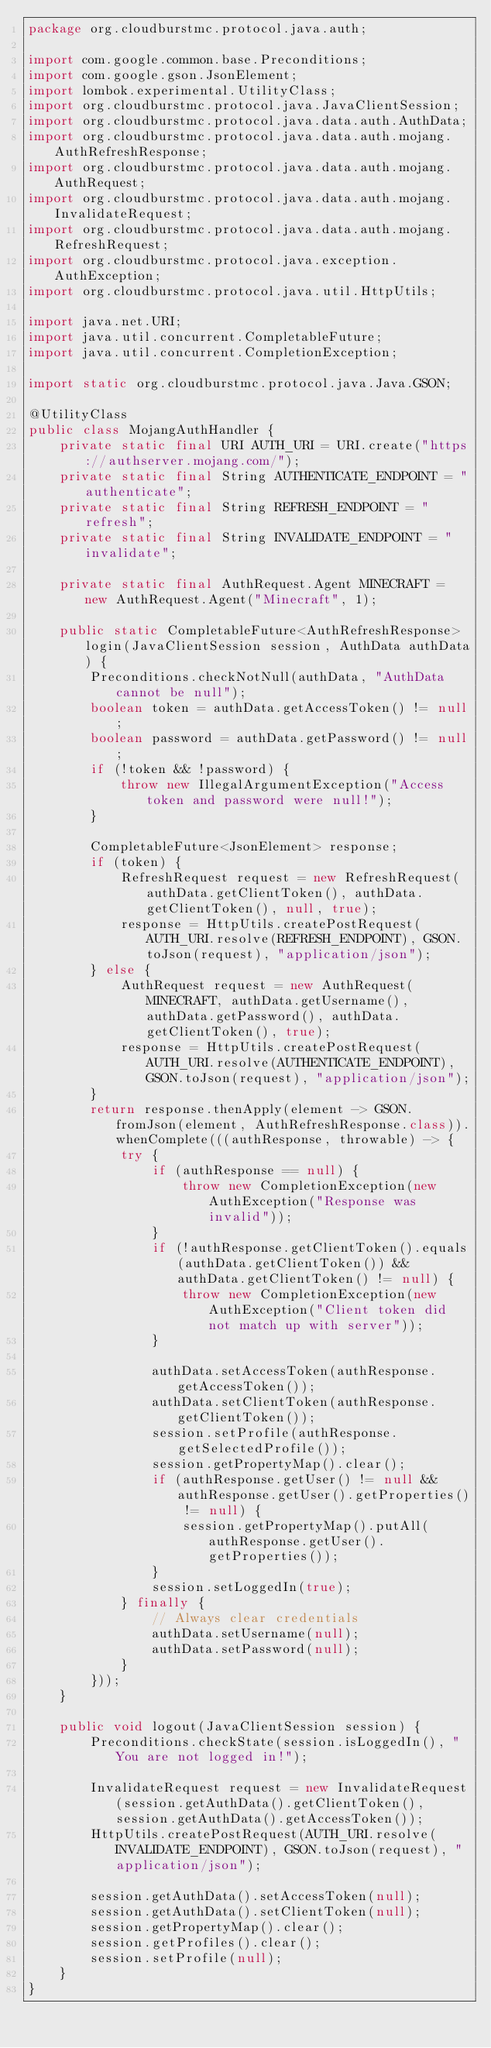<code> <loc_0><loc_0><loc_500><loc_500><_Java_>package org.cloudburstmc.protocol.java.auth;

import com.google.common.base.Preconditions;
import com.google.gson.JsonElement;
import lombok.experimental.UtilityClass;
import org.cloudburstmc.protocol.java.JavaClientSession;
import org.cloudburstmc.protocol.java.data.auth.AuthData;
import org.cloudburstmc.protocol.java.data.auth.mojang.AuthRefreshResponse;
import org.cloudburstmc.protocol.java.data.auth.mojang.AuthRequest;
import org.cloudburstmc.protocol.java.data.auth.mojang.InvalidateRequest;
import org.cloudburstmc.protocol.java.data.auth.mojang.RefreshRequest;
import org.cloudburstmc.protocol.java.exception.AuthException;
import org.cloudburstmc.protocol.java.util.HttpUtils;

import java.net.URI;
import java.util.concurrent.CompletableFuture;
import java.util.concurrent.CompletionException;

import static org.cloudburstmc.protocol.java.Java.GSON;

@UtilityClass
public class MojangAuthHandler {
    private static final URI AUTH_URI = URI.create("https://authserver.mojang.com/");
    private static final String AUTHENTICATE_ENDPOINT = "authenticate";
    private static final String REFRESH_ENDPOINT = "refresh";
    private static final String INVALIDATE_ENDPOINT = "invalidate";

    private static final AuthRequest.Agent MINECRAFT = new AuthRequest.Agent("Minecraft", 1);

    public static CompletableFuture<AuthRefreshResponse> login(JavaClientSession session, AuthData authData) {
        Preconditions.checkNotNull(authData, "AuthData cannot be null");
        boolean token = authData.getAccessToken() != null;
        boolean password = authData.getPassword() != null;
        if (!token && !password) {
            throw new IllegalArgumentException("Access token and password were null!");
        }

        CompletableFuture<JsonElement> response;
        if (token) {
            RefreshRequest request = new RefreshRequest(authData.getClientToken(), authData.getClientToken(), null, true);
            response = HttpUtils.createPostRequest(AUTH_URI.resolve(REFRESH_ENDPOINT), GSON.toJson(request), "application/json");
        } else {
            AuthRequest request = new AuthRequest(MINECRAFT, authData.getUsername(), authData.getPassword(), authData.getClientToken(), true);
            response = HttpUtils.createPostRequest(AUTH_URI.resolve(AUTHENTICATE_ENDPOINT), GSON.toJson(request), "application/json");
        }
        return response.thenApply(element -> GSON.fromJson(element, AuthRefreshResponse.class)).whenComplete(((authResponse, throwable) -> {
            try {
                if (authResponse == null) {
                    throw new CompletionException(new AuthException("Response was invalid"));
                }
                if (!authResponse.getClientToken().equals(authData.getClientToken()) && authData.getClientToken() != null) {
                    throw new CompletionException(new AuthException("Client token did not match up with server"));
                }

                authData.setAccessToken(authResponse.getAccessToken());
                authData.setClientToken(authResponse.getClientToken());
                session.setProfile(authResponse.getSelectedProfile());
                session.getPropertyMap().clear();
                if (authResponse.getUser() != null && authResponse.getUser().getProperties() != null) {
                    session.getPropertyMap().putAll(authResponse.getUser().getProperties());
                }
                session.setLoggedIn(true);
            } finally {
                // Always clear credentials
                authData.setUsername(null);
                authData.setPassword(null);
            }
        }));
    }

    public void logout(JavaClientSession session) {
        Preconditions.checkState(session.isLoggedIn(), "You are not logged in!");

        InvalidateRequest request = new InvalidateRequest(session.getAuthData().getClientToken(), session.getAuthData().getAccessToken());
        HttpUtils.createPostRequest(AUTH_URI.resolve(INVALIDATE_ENDPOINT), GSON.toJson(request), "application/json");

        session.getAuthData().setAccessToken(null);
        session.getAuthData().setClientToken(null);
        session.getPropertyMap().clear();
        session.getProfiles().clear();
        session.setProfile(null);
    }
}
</code> 